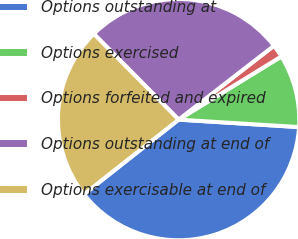Convert chart. <chart><loc_0><loc_0><loc_500><loc_500><pie_chart><fcel>Options outstanding at<fcel>Options exercised<fcel>Options forfeited and expired<fcel>Options outstanding at end of<fcel>Options exercisable at end of<nl><fcel>38.39%<fcel>9.76%<fcel>1.72%<fcel>26.92%<fcel>23.22%<nl></chart> 